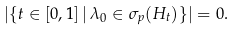<formula> <loc_0><loc_0><loc_500><loc_500>| \{ t \in [ 0 , 1 ] \, | \, \lambda _ { 0 } \in \sigma _ { p } ( H _ { t } ) \} | = 0 .</formula> 